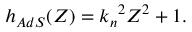<formula> <loc_0><loc_0><loc_500><loc_500>h _ { A d S } ( Z ) = { k _ { n } } ^ { 2 } Z ^ { 2 } + 1 .</formula> 